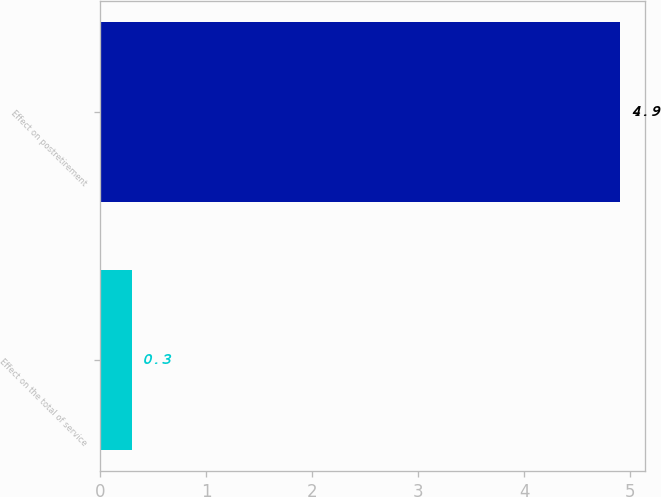Convert chart to OTSL. <chart><loc_0><loc_0><loc_500><loc_500><bar_chart><fcel>Effect on the total of service<fcel>Effect on postretirement<nl><fcel>0.3<fcel>4.9<nl></chart> 